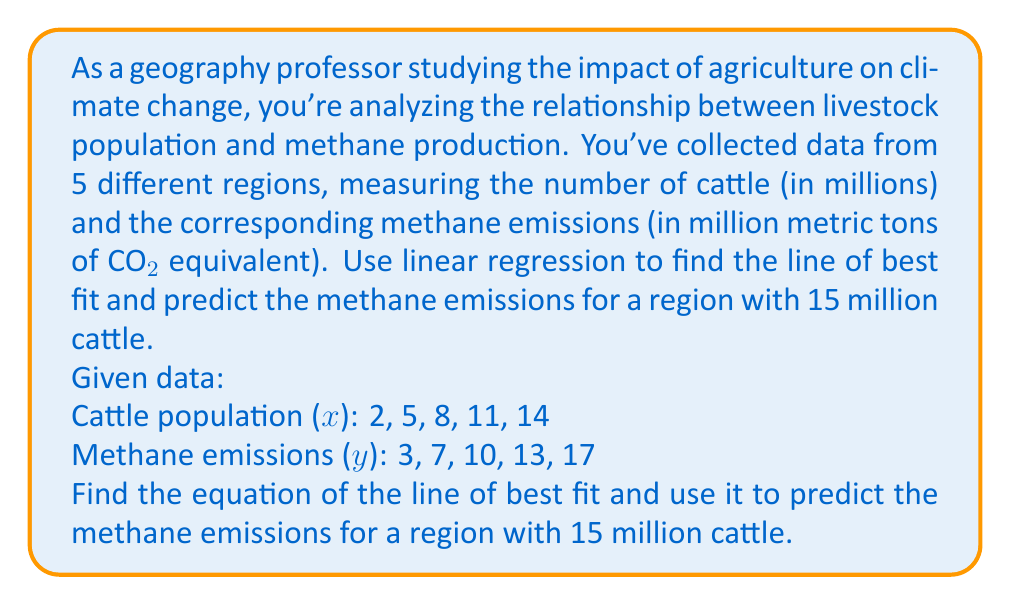Could you help me with this problem? To solve this problem, we'll use the linear regression method to find the line of best fit, then use that equation to predict the methane emissions.

Step 1: Calculate the means of x and y
$\bar{x} = \frac{2 + 5 + 8 + 11 + 14}{5} = 8$
$\bar{y} = \frac{3 + 7 + 10 + 13 + 17}{5} = 10$

Step 2: Calculate the slope (m) using the formula:
$m = \frac{\sum(x_i - \bar{x})(y_i - \bar{y})}{\sum(x_i - \bar{x})^2}$

$\sum(x_i - \bar{x})(y_i - \bar{y}) = (-6)(-7) + (-3)(-3) + (0)(0) + (3)(3) + (6)(7) = 126$
$\sum(x_i - \bar{x})^2 = (-6)^2 + (-3)^2 + (0)^2 + (3)^2 + (6)^2 = 126$

$m = \frac{126}{126} = 1$

Step 3: Calculate the y-intercept (b) using the formula:
$b = \bar{y} - m\bar{x}$
$b = 10 - 1(8) = 2$

Step 4: Write the equation of the line of best fit
$y = mx + b$
$y = 1x + 2$

Step 5: Use the equation to predict methane emissions for 15 million cattle
$y = 1(15) + 2 = 17$

Therefore, the predicted methane emissions for a region with 15 million cattle would be 17 million metric tons of CO2 equivalent.
Answer: The equation of the line of best fit is $y = x + 2$, where $x$ is the cattle population in millions and $y$ is the methane emissions in million metric tons of CO2 equivalent. For a region with 15 million cattle, the predicted methane emissions would be 17 million metric tons of CO2 equivalent. 